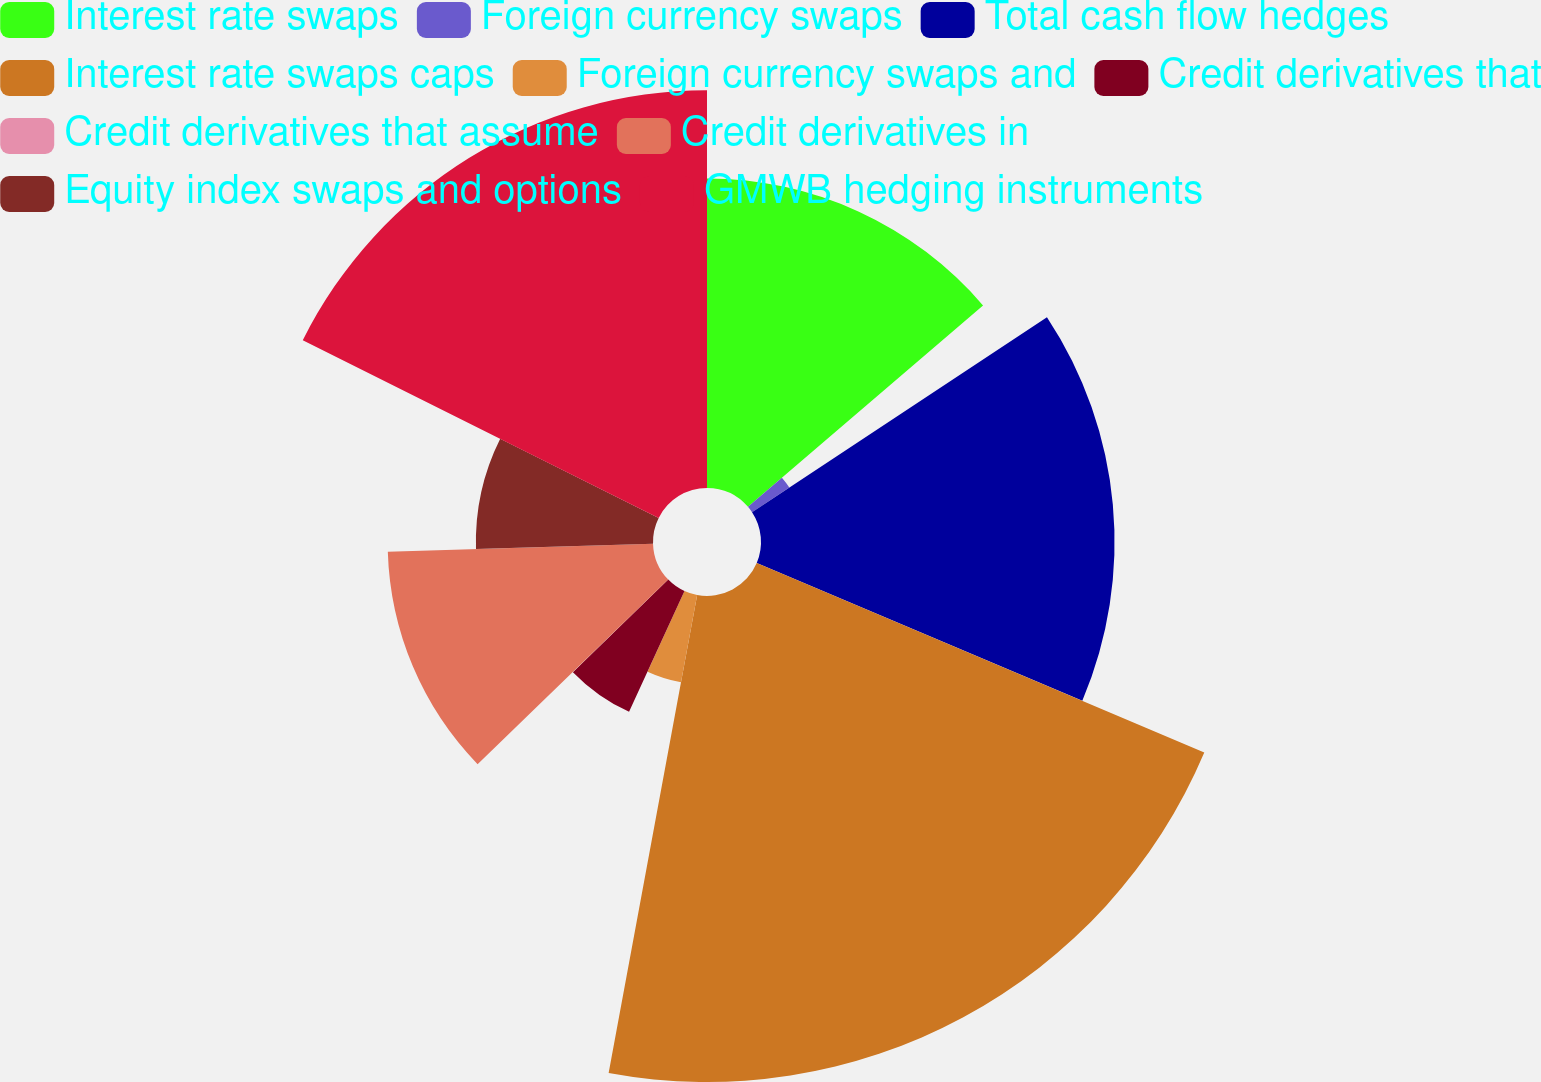Convert chart to OTSL. <chart><loc_0><loc_0><loc_500><loc_500><pie_chart><fcel>Interest rate swaps<fcel>Foreign currency swaps<fcel>Total cash flow hedges<fcel>Interest rate swaps caps<fcel>Foreign currency swaps and<fcel>Credit derivatives that<fcel>Credit derivatives that assume<fcel>Credit derivatives in<fcel>Equity index swaps and options<fcel>GMWB hedging instruments<nl><fcel>13.72%<fcel>1.98%<fcel>15.67%<fcel>21.54%<fcel>3.93%<fcel>5.89%<fcel>0.02%<fcel>11.76%<fcel>7.85%<fcel>17.63%<nl></chart> 